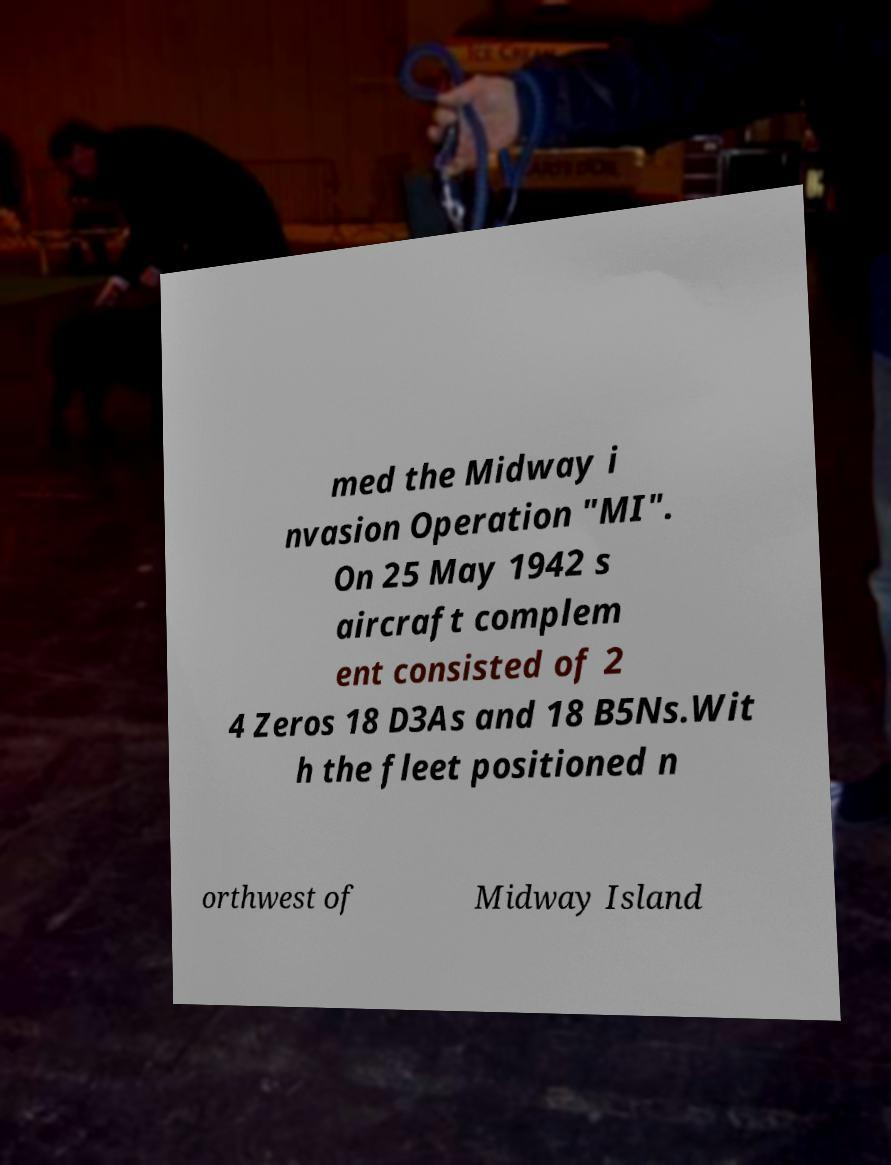For documentation purposes, I need the text within this image transcribed. Could you provide that? med the Midway i nvasion Operation "MI". On 25 May 1942 s aircraft complem ent consisted of 2 4 Zeros 18 D3As and 18 B5Ns.Wit h the fleet positioned n orthwest of Midway Island 